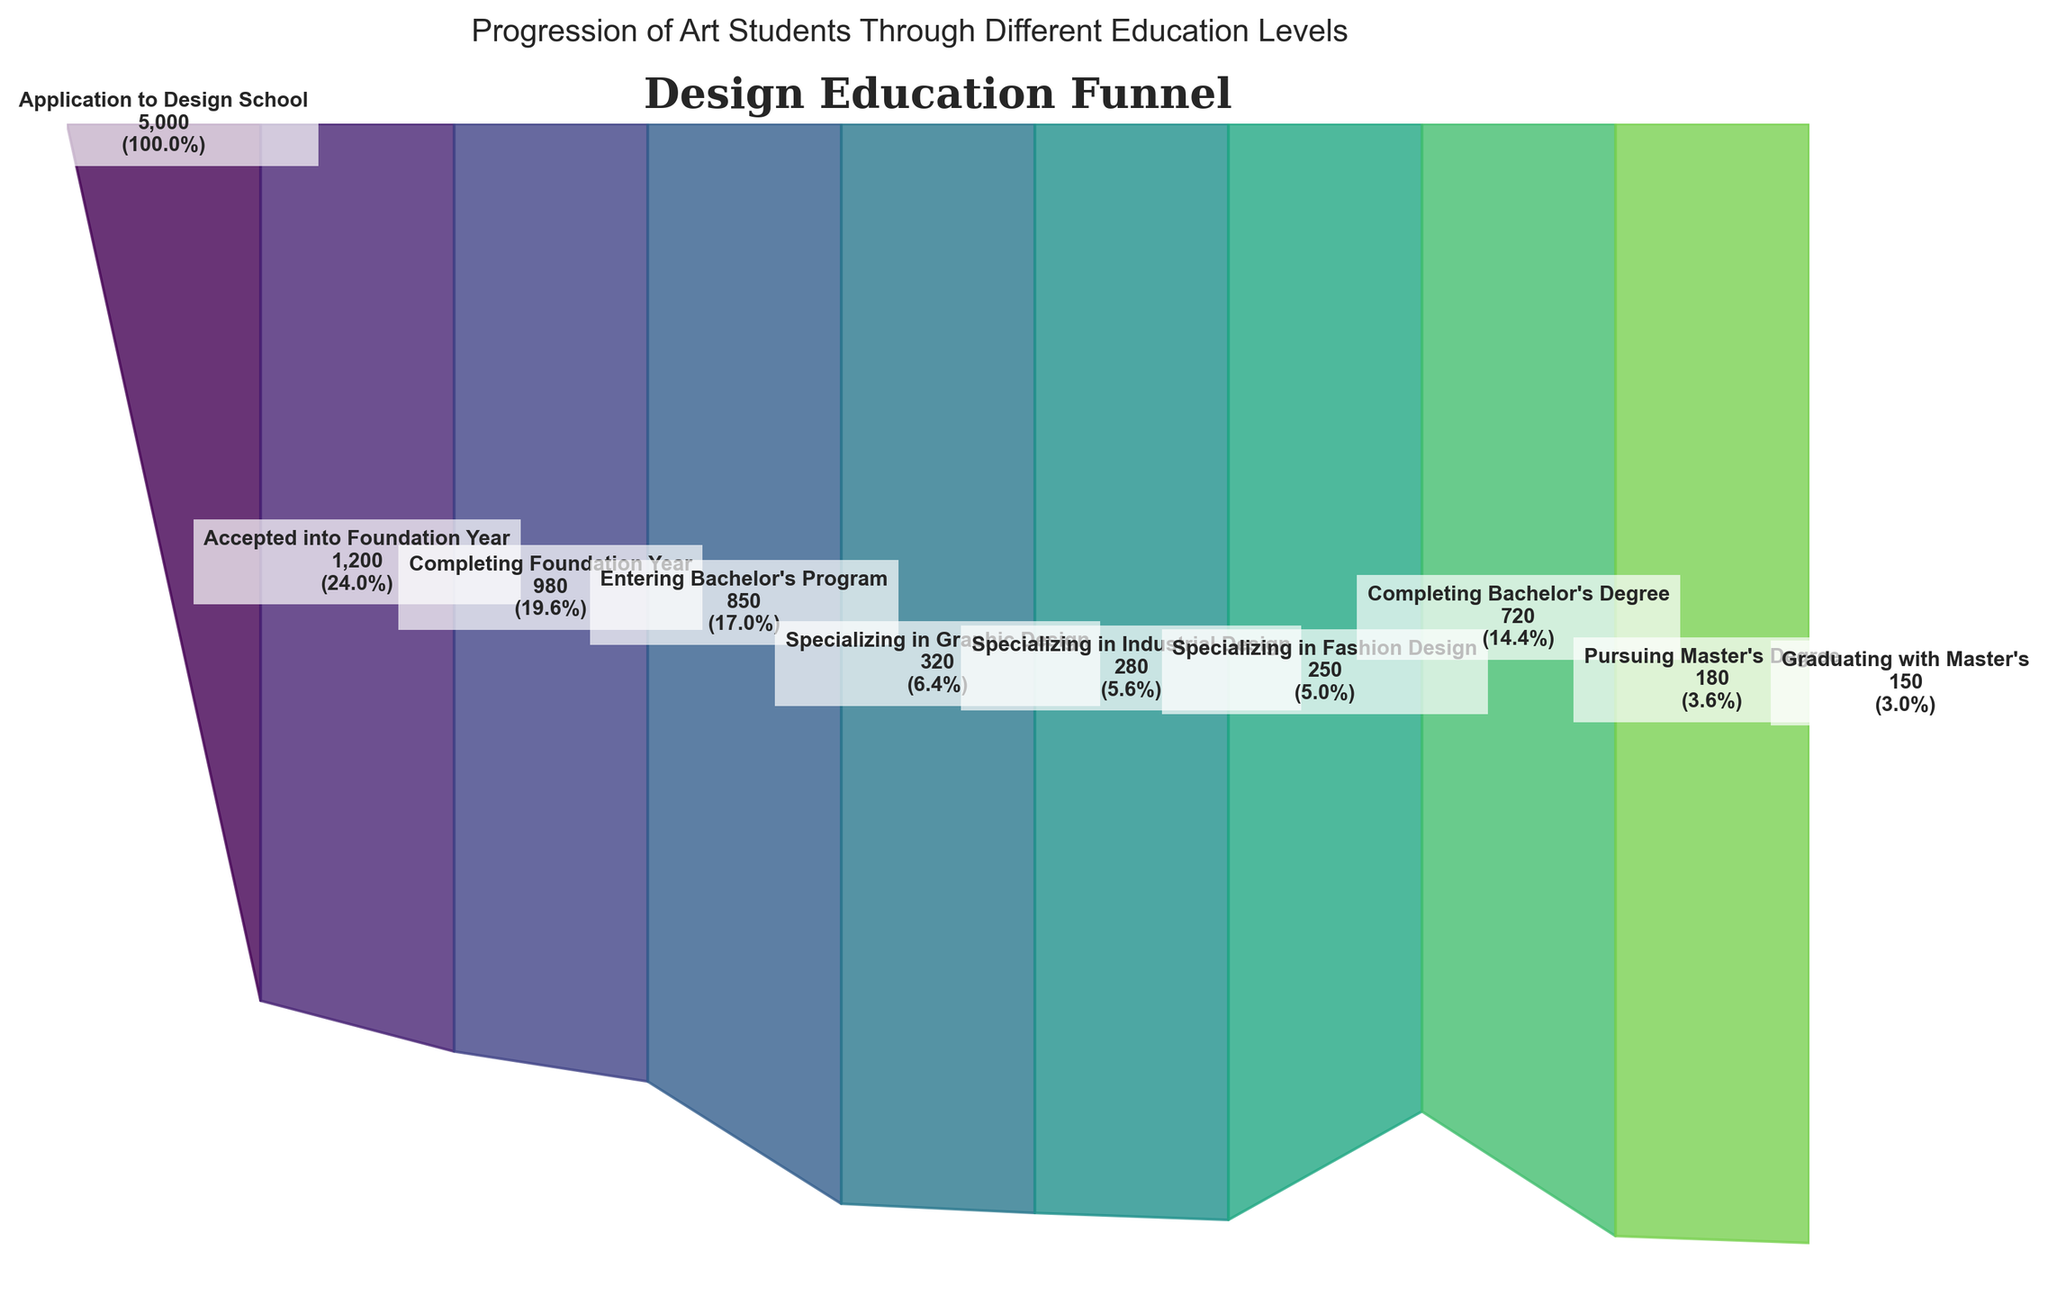What is the highest number of students at any stage? The highest number of students is at the application stage, which is shown at the beginning of the funnel chart with 5000 students.
Answer: 5000 How many students specialized in Graphic Design? The number of students specializing in Graphic Design is explicitly labeled in the funnel chart as 320 students.
Answer: 320 At which stage do we see the biggest drop in the number of students? The largest drop occurs from the Application to Design School stage (5000 students) to the Accepted into Foundation Year stage (1200 students), which is a reduction of 3800 students.
Answer: Application to Foundation Year What percentage of students who started the application completed the Bachelor's Degree? The figure shows that 720 students completed their Bachelor's Degree. The percentage is calculated as (720 / 5000) * 100%. So, (720 / 5000) * 100% = 14.4%.
Answer: 14.4% How many students specialized in Industrial Design and Fashion Design combined? The chart shows 280 students specializing in Industrial Design and 250 students in Fashion Design. Their combined total is 280 + 250 = 530 students.
Answer: 530 Which specialization has the fewest number of students? The chart shows that the fewest number of students specialize in Fashion Design with 250 students.
Answer: Fashion Design How many students transition from the Foundation Year to the Bachelor's Program? The funnel chart indicates 980 students completed the Foundation Year and 850 entered the Bachelor's Program, giving a difference of 980 - 850 = 130 students.
Answer: 130 What is the smallest percentage among the stages shown? The smallest percentage is for Graduating with a Master's degree, which is represented as 3% on the funnel chart.
Answer: 3% Compare the number of students pursuing a Master's Degree to those graduating with a Bachelor's Degree. The funnel chart shows that 180 students pursue a Master's Degree, while 720 complete their Bachelor's. The difference is 720 - 180 = 540 more students complete their Bachelor's.
Answer: 540 What percentage of students specialize in Graphic Design out of those entering the Bachelor's Program? The chart indicates 850 students enter the Bachelor's Program and 320 specialize in Graphic Design. The percentage is (320 / 850) * 100%. So, (320 / 850) * 100% = 37.6%.
Answer: 37.6% 